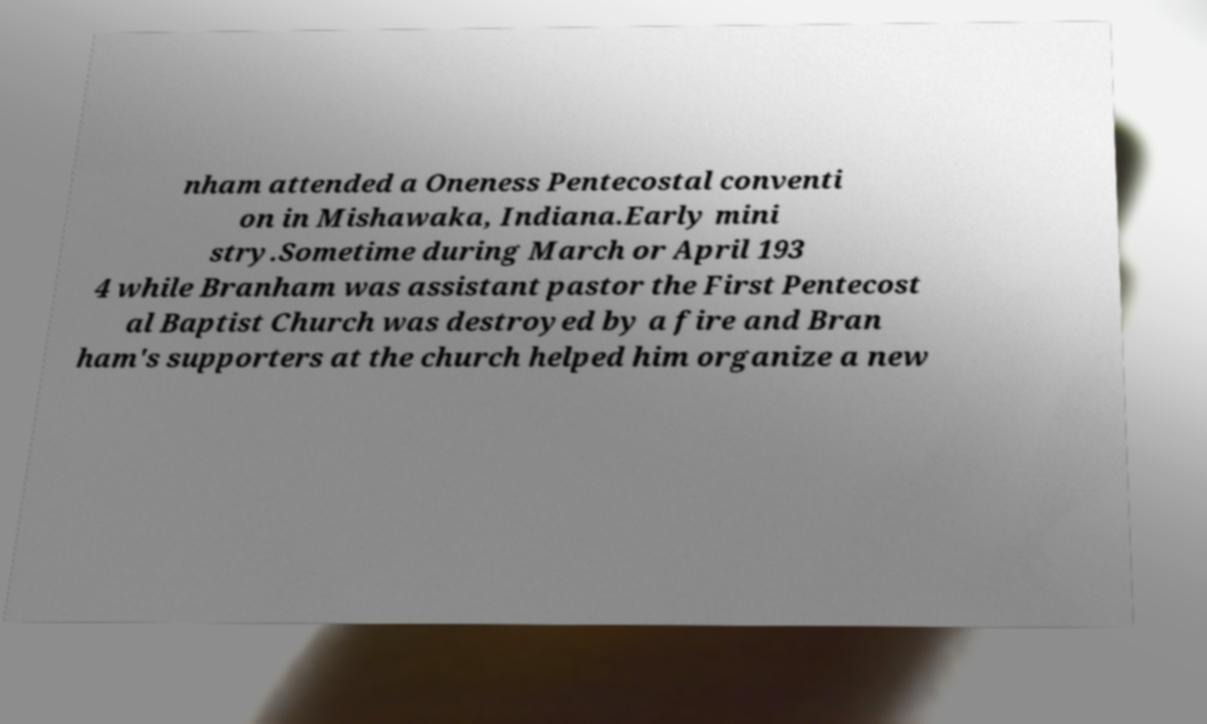Could you assist in decoding the text presented in this image and type it out clearly? nham attended a Oneness Pentecostal conventi on in Mishawaka, Indiana.Early mini stry.Sometime during March or April 193 4 while Branham was assistant pastor the First Pentecost al Baptist Church was destroyed by a fire and Bran ham's supporters at the church helped him organize a new 